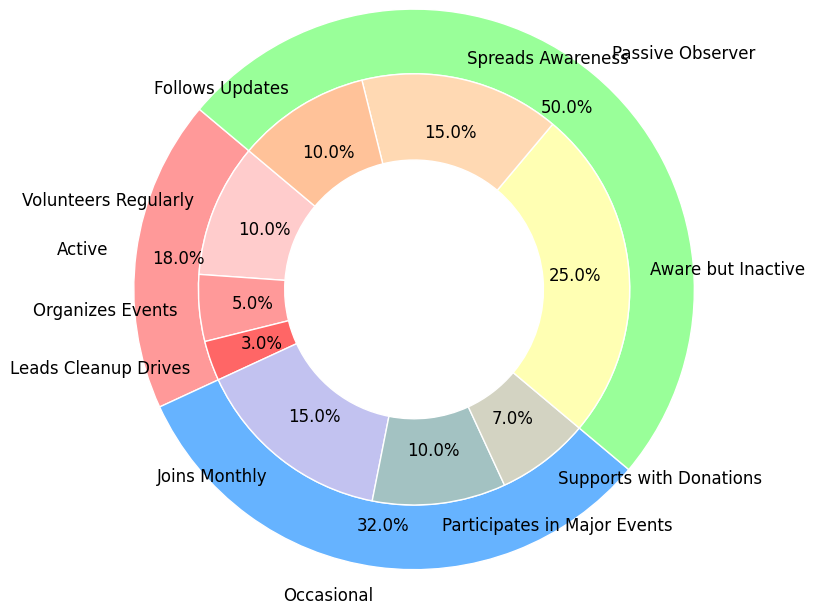Which category has the highest overall involvement percentage? The categories are "Active," "Occasional," and "Passive Observer." We can see from the outer ring of the pie chart that "Passive Observer" has the largest section. Each slice is labeled with percentages, and "Passive Observer" has 50%.
Answer: Passive Observer How much more percentage does the "Passive Observer" category have compared to the "Occasional" category? The "Passive Observer" category is 50%, and the "Occasional" category is 32%. To find the difference, subtract 32% from 50%.
Answer: 18% Which subcategory within the "Occasional" category has the highest participation? From the inner ring slices related to "Occasional," we see three subcategories: "Joins Monthly," "Participates in Major Events," and "Supports with Donations." "Joins Monthly" has the highest percentage labeled as 15%.
Answer: Joins Monthly What is the combined percentage of people "Leads Cleanup Drives" and "Organizes Events" within the "Active" category? Within the "Active" category in the inner ring, "Leads Cleanup Drives" is 3%, and "Organizes Events" is 5%. Summing these up gives 3% + 5%.
Answer: 8% Is the proportion of people who "Follow Updates" greater than those who "Lead Cleanup Drives"? "Follows Updates" is 10%, and "Leads Cleanup Drives" is 3%, both percentages are shown on the inner segments of the chart. 10% is greater than 3%.
Answer: Yes What percentage of participants "Supports with Donations" within the "Occasional" category? In the inner ring, the segment labeled "Supports with Donations" under the "Occasional" category shows 7%.
Answer: 7% What is the total percentage of the "Active" category? Summing up the subcategories within "Active": "Volunteers Regularly" (10%), "Organizes Events" (5%), and "Leads Cleanup Drives" (3%) gives 10% + 5% + 3%.
Answer: 18% Which has a higher percentage: "Spreads Awareness" or "Organizes Events"? "Spreads Awareness" has 15%, and "Organizes Events" has 5%. 15% is greater than 5%. These values are labeled on the inner ring.
Answer: Spreads Awareness How does the participation in "Volunteers Regularly" compare to "Participates in Major Events"? "Volunteers Regularly" shows 10%, while "Participates in Major Events" shows 10%. Both the inner ring segments are equal, meaning their participation is the same.
Answer: Equal What is the total percentage represented by passive participants (those in the "Passive Observer" category)? Sum of "Aware but Inactive" (25%), "Spreads Awareness" (15%), "Follows Updates" (10%) under the "Passive Observer" category. So, 25% + 15% + 10%.
Answer: 50% 